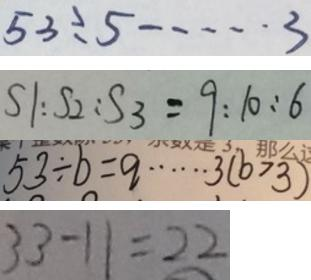<formula> <loc_0><loc_0><loc_500><loc_500>5 3 \div 5 \cdots 3 
 S 1 : S 2 : S 3 = 9 : 1 0 : 6 
 5 3 \div b = q \cdots 3 ( b > 3 ) 
 3 3 - 1 1 = 2 2</formula> 